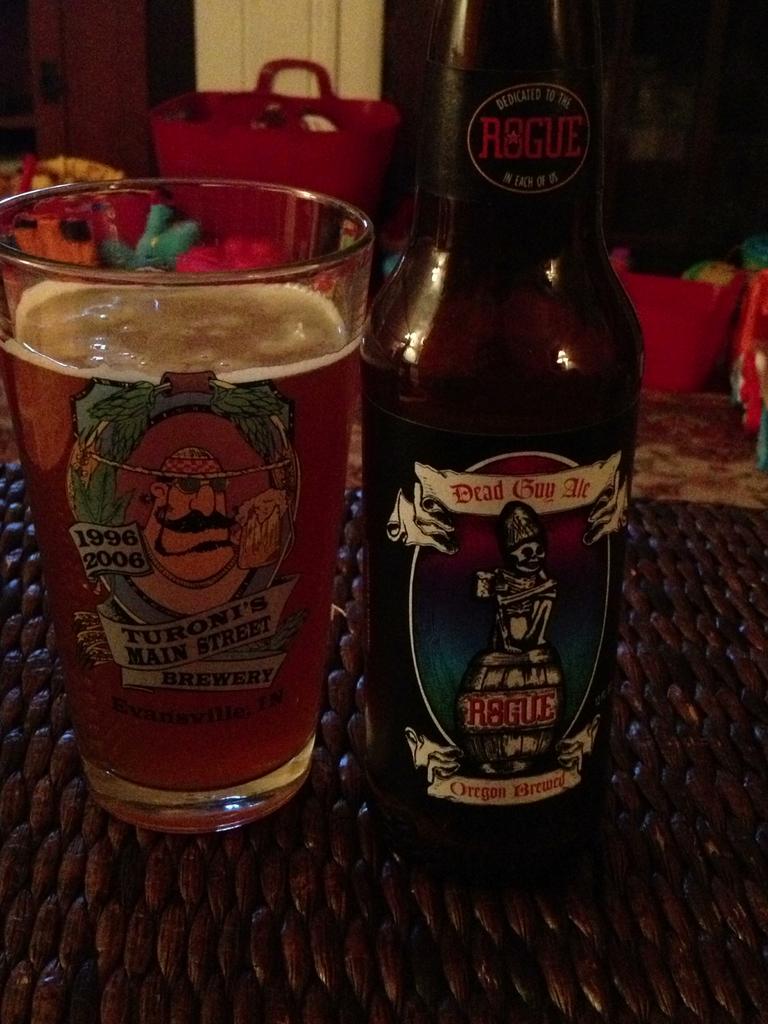Where was the dead guy ale brewed?
Your response must be concise. Oregon. 